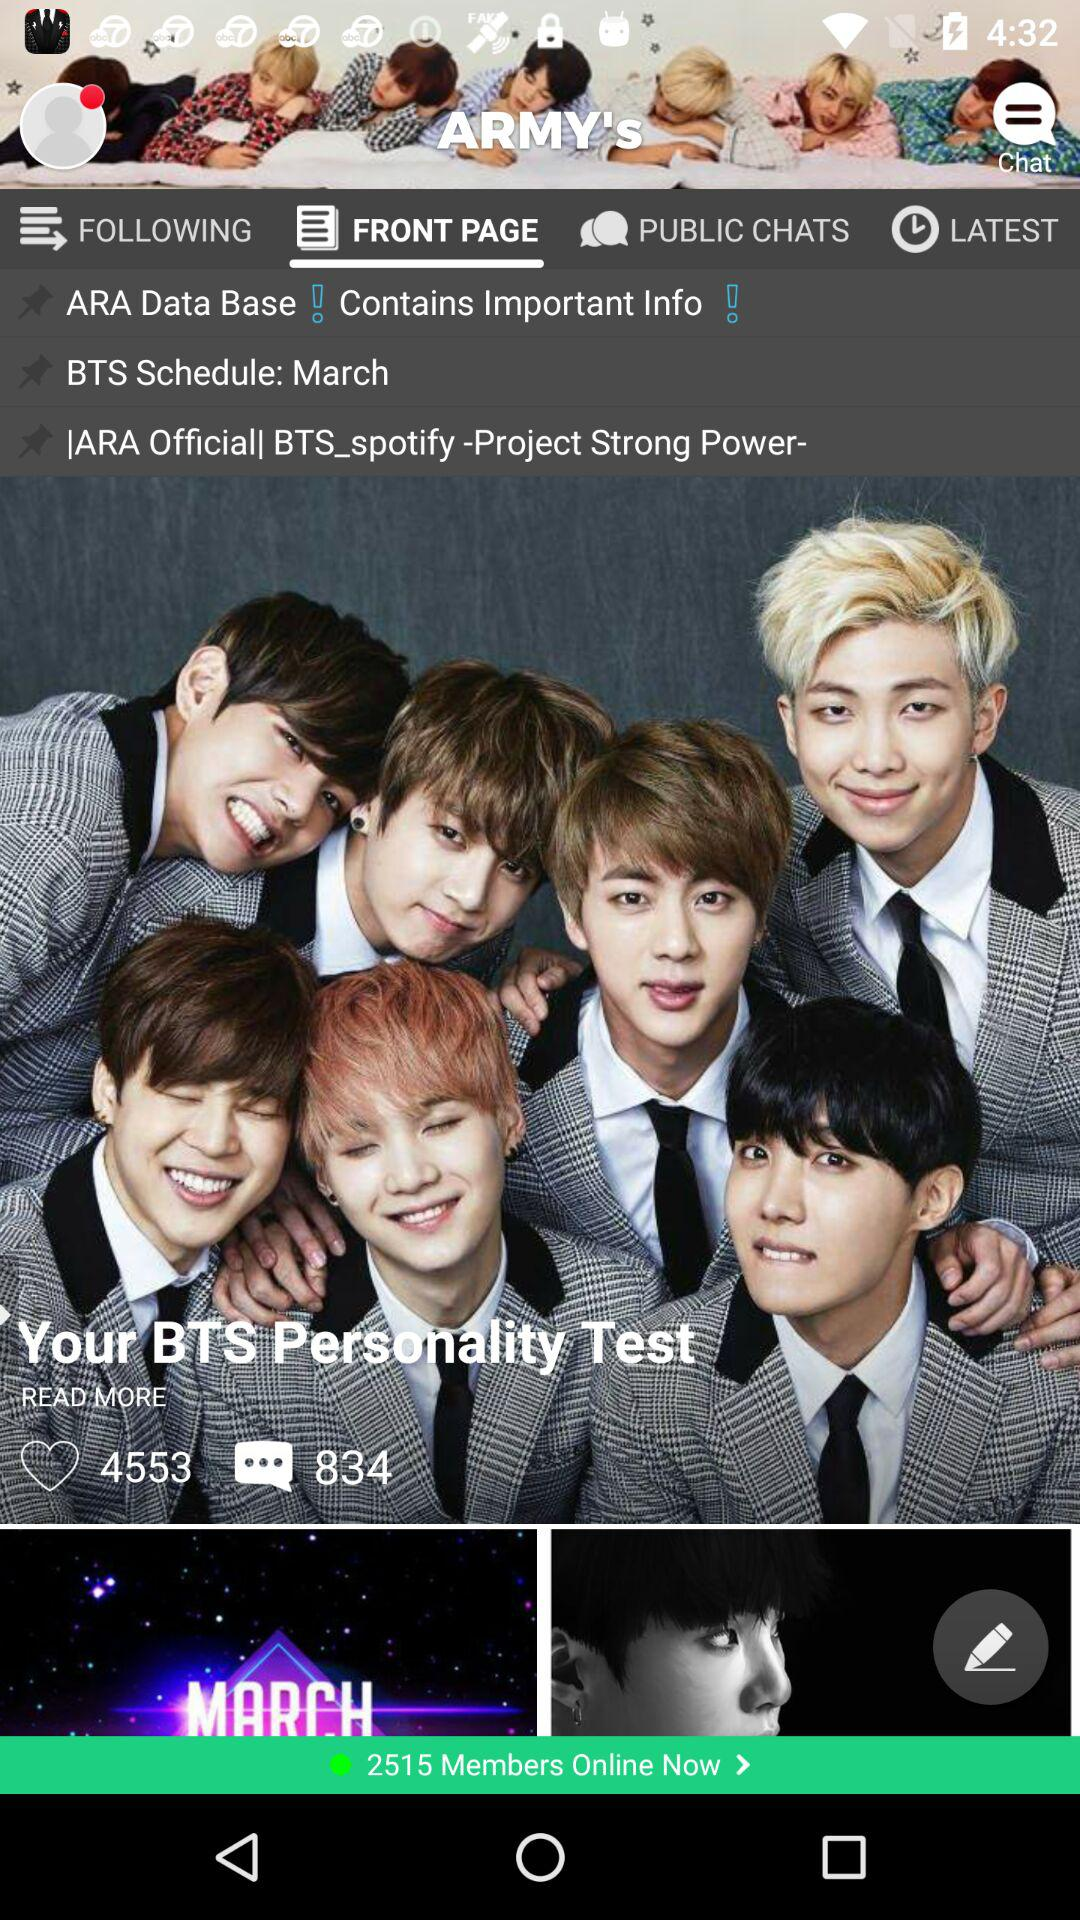For what month has the BTS event been scheduled? The BTS event has been scheduled for March. 